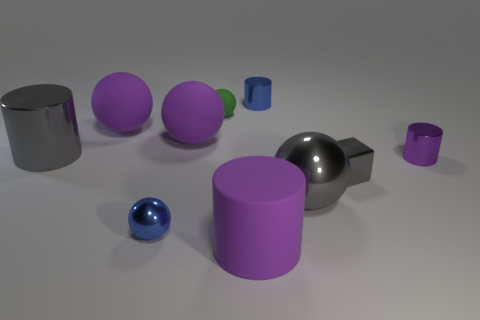There is a ball that is the same color as the shiny block; what size is it?
Make the answer very short. Large. Are there any large blocks made of the same material as the large gray cylinder?
Ensure brevity in your answer.  No. What number of things are either shiny things that are behind the small green object or purple rubber objects that are to the left of the big purple cylinder?
Offer a terse response. 3. There is a small green rubber object; is its shape the same as the small blue metal object in front of the large metal cylinder?
Provide a short and direct response. Yes. What number of other things are there of the same shape as the small green thing?
Make the answer very short. 4. What number of things are either large cubes or gray spheres?
Your response must be concise. 1. Does the tiny block have the same color as the big shiny ball?
Offer a very short reply. Yes. Are there any other things that have the same size as the rubber cylinder?
Offer a very short reply. Yes. There is a tiny blue metallic object that is right of the blue metal object that is in front of the tiny gray metal block; what is its shape?
Your answer should be very brief. Cylinder. Are there fewer large brown objects than large metallic cylinders?
Provide a succinct answer. Yes. 